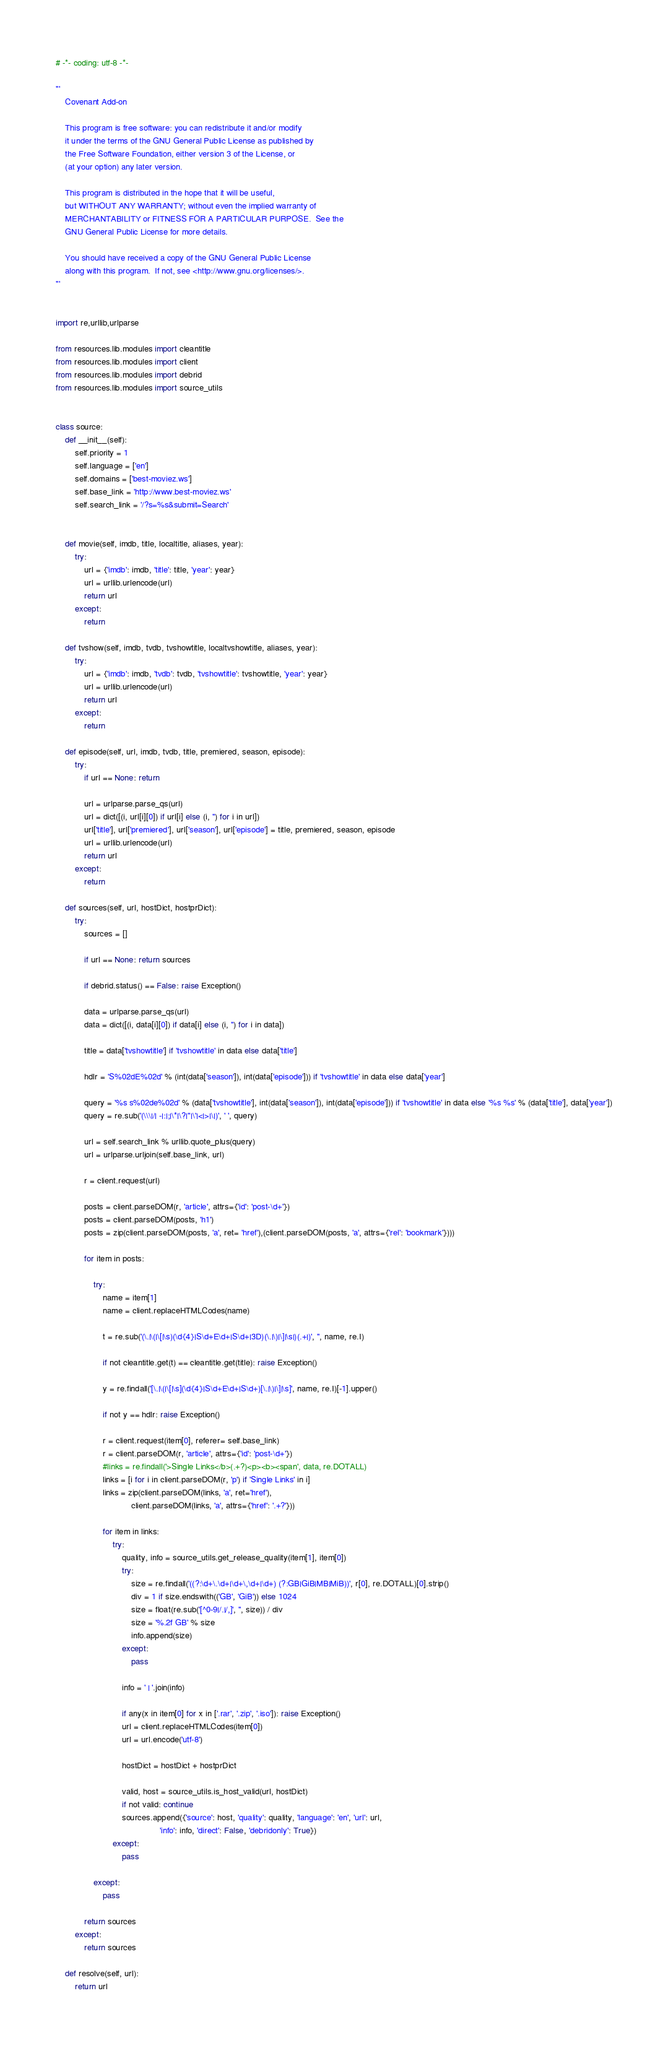<code> <loc_0><loc_0><loc_500><loc_500><_Python_># -*- coding: utf-8 -*-

'''
    Covenant Add-on

    This program is free software: you can redistribute it and/or modify
    it under the terms of the GNU General Public License as published by
    the Free Software Foundation, either version 3 of the License, or
    (at your option) any later version.

    This program is distributed in the hope that it will be useful,
    but WITHOUT ANY WARRANTY; without even the implied warranty of
    MERCHANTABILITY or FITNESS FOR A PARTICULAR PURPOSE.  See the
    GNU General Public License for more details.

    You should have received a copy of the GNU General Public License
    along with this program.  If not, see <http://www.gnu.org/licenses/>.
'''


import re,urllib,urlparse

from resources.lib.modules import cleantitle
from resources.lib.modules import client
from resources.lib.modules import debrid
from resources.lib.modules import source_utils


class source:
    def __init__(self):
        self.priority = 1
        self.language = ['en']
        self.domains = ['best-moviez.ws']
        self.base_link = 'http://www.best-moviez.ws'
        self.search_link = '/?s=%s&submit=Search'


    def movie(self, imdb, title, localtitle, aliases, year):
        try:
            url = {'imdb': imdb, 'title': title, 'year': year}
            url = urllib.urlencode(url)
            return url
        except:
            return

    def tvshow(self, imdb, tvdb, tvshowtitle, localtvshowtitle, aliases, year):
        try:
            url = {'imdb': imdb, 'tvdb': tvdb, 'tvshowtitle': tvshowtitle, 'year': year}
            url = urllib.urlencode(url)
            return url
        except:
            return

    def episode(self, url, imdb, tvdb, title, premiered, season, episode):
        try:
            if url == None: return

            url = urlparse.parse_qs(url)
            url = dict([(i, url[i][0]) if url[i] else (i, '') for i in url])
            url['title'], url['premiered'], url['season'], url['episode'] = title, premiered, season, episode
            url = urllib.urlencode(url)
            return url
        except:
            return

    def sources(self, url, hostDict, hostprDict):
        try:
            sources = []

            if url == None: return sources

            if debrid.status() == False: raise Exception()

            data = urlparse.parse_qs(url)
            data = dict([(i, data[i][0]) if data[i] else (i, '') for i in data])

            title = data['tvshowtitle'] if 'tvshowtitle' in data else data['title']

            hdlr = 'S%02dE%02d' % (int(data['season']), int(data['episode'])) if 'tvshowtitle' in data else data['year']

            query = '%s s%02de%02d' % (data['tvshowtitle'], int(data['season']), int(data['episode'])) if 'tvshowtitle' in data else '%s %s' % (data['title'], data['year'])
            query = re.sub('(\\\|/| -|:|;|\*|\?|"|\'|<|>|\|)', ' ', query)

            url = self.search_link % urllib.quote_plus(query)
            url = urlparse.urljoin(self.base_link, url)

            r = client.request(url)

            posts = client.parseDOM(r, 'article', attrs={'id': 'post-\d+'})
            posts = client.parseDOM(posts, 'h1')
            posts = zip(client.parseDOM(posts, 'a', ret= 'href'),(client.parseDOM(posts, 'a', attrs={'rel': 'bookmark'})))

            for item in posts:

                try:
                    name = item[1]
                    name = client.replaceHTMLCodes(name)

                    t = re.sub('(\.|\(|\[|\s)(\d{4}|S\d+E\d+|S\d+|3D)(\.|\)|\]|\s|)(.+|)', '', name, re.I)

                    if not cleantitle.get(t) == cleantitle.get(title): raise Exception()

                    y = re.findall('[\.|\(|\[|\s](\d{4}|S\d+E\d+|S\d+)[\.|\)|\]|\s]', name, re.I)[-1].upper()

                    if not y == hdlr: raise Exception()

                    r = client.request(item[0], referer= self.base_link)
                    r = client.parseDOM(r, 'article', attrs={'id': 'post-\d+'})
                    #links = re.findall('>Single Links</b>(.+?)<p><b><span', data, re.DOTALL)
                    links = [i for i in client.parseDOM(r, 'p') if 'Single Links' in i]
                    links = zip(client.parseDOM(links, 'a', ret='href'),
                                client.parseDOM(links, 'a', attrs={'href': '.+?'}))

                    for item in links:
                        try:
                            quality, info = source_utils.get_release_quality(item[1], item[0])
                            try:
                                size = re.findall('((?:\d+\.\d+|\d+\,\d+|\d+) (?:GB|GiB|MB|MiB))', r[0], re.DOTALL)[0].strip()
                                div = 1 if size.endswith(('GB', 'GiB')) else 1024
                                size = float(re.sub('[^0-9|/.|/,]', '', size)) / div
                                size = '%.2f GB' % size
                                info.append(size)
                            except:
                                pass

                            info = ' | '.join(info)

                            if any(x in item[0] for x in ['.rar', '.zip', '.iso']): raise Exception()
                            url = client.replaceHTMLCodes(item[0])
                            url = url.encode('utf-8')

                            hostDict = hostDict + hostprDict

                            valid, host = source_utils.is_host_valid(url, hostDict)
                            if not valid: continue
                            sources.append({'source': host, 'quality': quality, 'language': 'en', 'url': url,
                                            'info': info, 'direct': False, 'debridonly': True})
                        except:
                            pass

                except:
                    pass

            return sources
        except:
            return sources

    def resolve(self, url):
        return url


</code> 